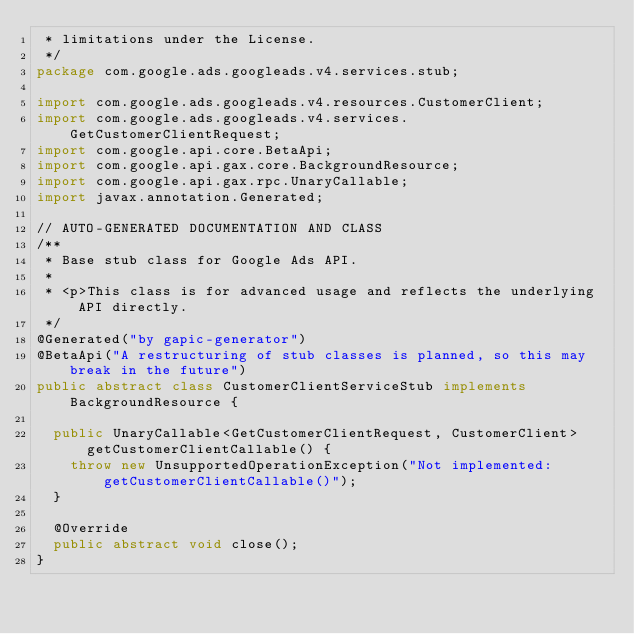<code> <loc_0><loc_0><loc_500><loc_500><_Java_> * limitations under the License.
 */
package com.google.ads.googleads.v4.services.stub;

import com.google.ads.googleads.v4.resources.CustomerClient;
import com.google.ads.googleads.v4.services.GetCustomerClientRequest;
import com.google.api.core.BetaApi;
import com.google.api.gax.core.BackgroundResource;
import com.google.api.gax.rpc.UnaryCallable;
import javax.annotation.Generated;

// AUTO-GENERATED DOCUMENTATION AND CLASS
/**
 * Base stub class for Google Ads API.
 *
 * <p>This class is for advanced usage and reflects the underlying API directly.
 */
@Generated("by gapic-generator")
@BetaApi("A restructuring of stub classes is planned, so this may break in the future")
public abstract class CustomerClientServiceStub implements BackgroundResource {

  public UnaryCallable<GetCustomerClientRequest, CustomerClient> getCustomerClientCallable() {
    throw new UnsupportedOperationException("Not implemented: getCustomerClientCallable()");
  }

  @Override
  public abstract void close();
}
</code> 